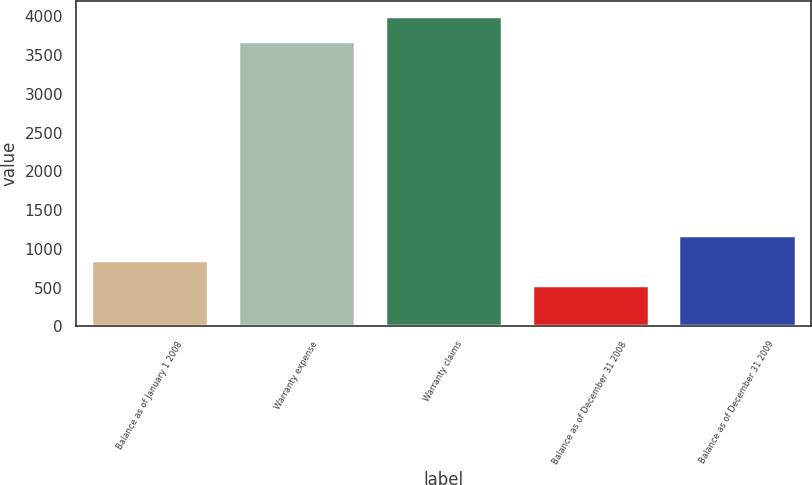Convert chart to OTSL. <chart><loc_0><loc_0><loc_500><loc_500><bar_chart><fcel>Balance as of January 1 2008<fcel>Warranty expense<fcel>Warranty claims<fcel>Balance as of December 31 2008<fcel>Balance as of December 31 2009<nl><fcel>858.1<fcel>3681<fcel>3999.1<fcel>540<fcel>1176.2<nl></chart> 